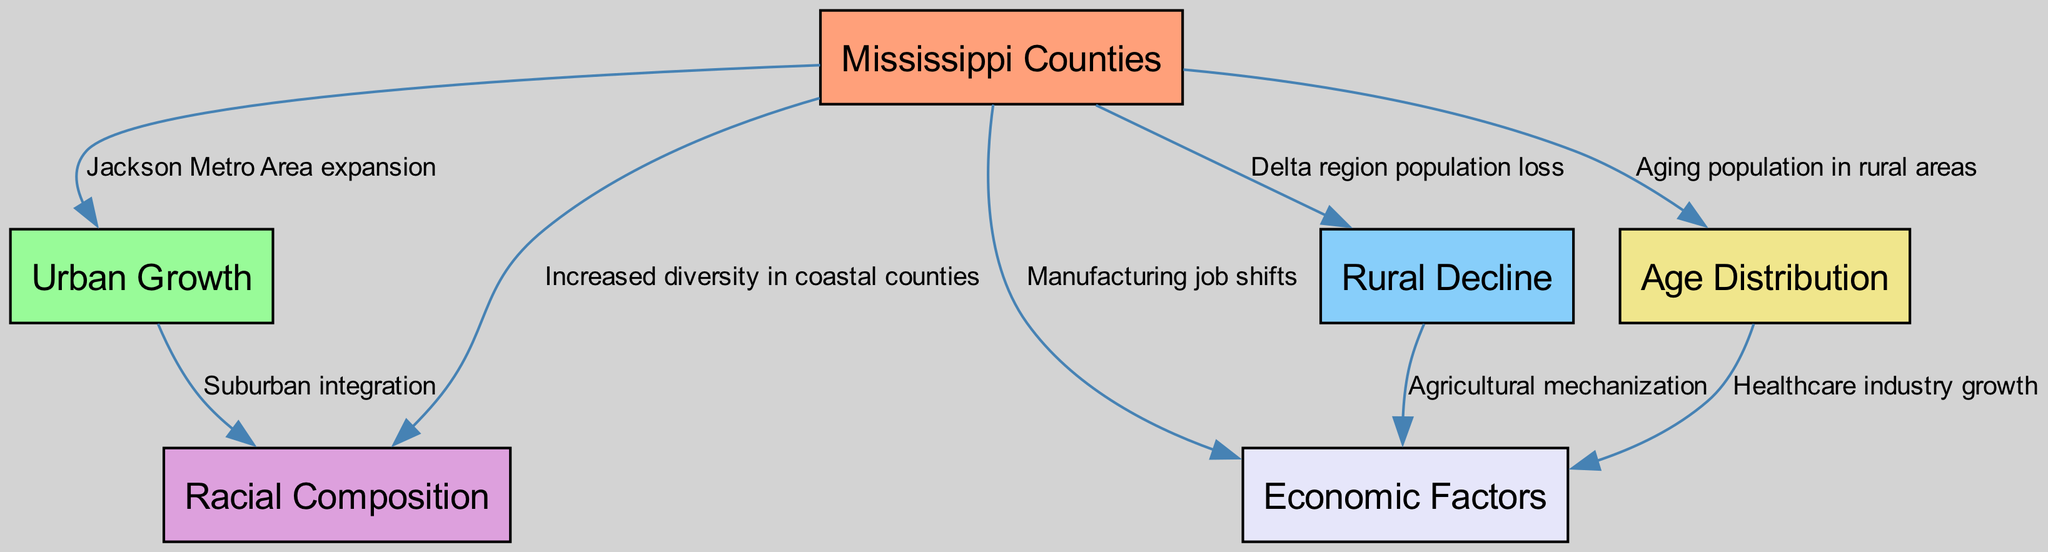What is the primary factor for urban growth in Mississippi counties? The diagram indicates "Jackson Metro Area expansion" as the connecting edge from "Mississippi Counties" to "Urban Growth," implying that it is a key driver for urban growth in the region.
Answer: Jackson Metro Area expansion How many nodes are present in the diagram? By counting the entries under the "nodes" section of the data, there are a total of six distinct nodes: Mississippi Counties, Urban Growth, Rural Decline, Racial Composition, Age Distribution, and Economic Factors.
Answer: 6 What trend does the "Delta region" show according to the diagram? The edge from "Mississippi Counties" to "Rural Decline" labeled "Delta region population loss" indicates that the Delta region is experiencing a trend of population loss, highlighting a decline.
Answer: Population loss Which two nodes are connected by the label "Suburban integration"? The label "Suburban integration" connects "Urban Growth" and "Racial Composition" in the diagram, indicating a relationship between these two factors in the context of demographics.
Answer: Urban Growth and Racial Composition What relationship does "Agricultural mechanization" indicate in the diagram? The edge from "Rural Decline" to "Economic Factors" marked with "Agricultural mechanization" illustrates that the mechanization in agriculture is linked to changes impacting the economy, particularly in rural areas.
Answer: Economic Factors What factor is leading to an aging population in rural areas? The diagram shows "Aging population in rural areas" is linked directly to "Age Distribution," implying that the aging demographic is a defining aspect of population dynamics in these regions.
Answer: Age Distribution Which demographic factor has increased diversity specifically in coastal counties? The diagram indicates "Increased diversity in coastal counties" through the connection between "Mississippi Counties" and "Racial Composition," highlighting demographic changes along the coast.
Answer: Racial Composition How does the healthcare industry relate to age distribution? The edge from "Age Distribution" to "Economic Factors" labeled "Healthcare industry growth" suggests that as the age distribution shifts, it drives growth in the healthcare industry to accommodate an aging population's needs.
Answer: Healthcare industry growth 